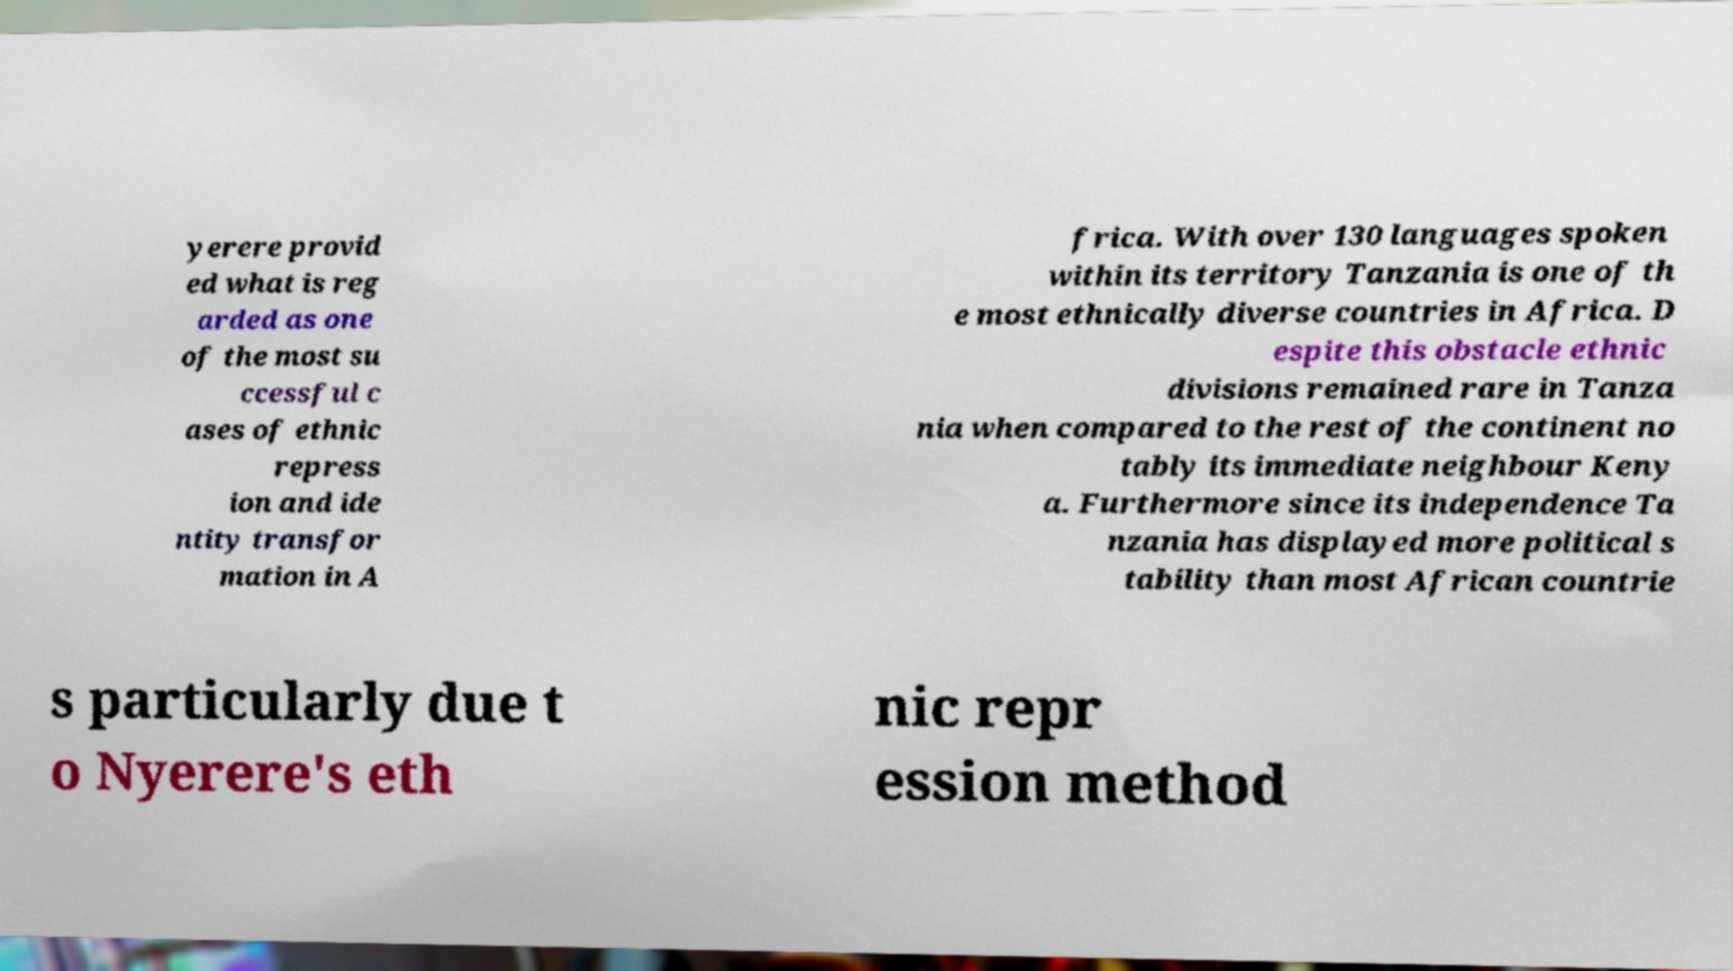Can you read and provide the text displayed in the image?This photo seems to have some interesting text. Can you extract and type it out for me? yerere provid ed what is reg arded as one of the most su ccessful c ases of ethnic repress ion and ide ntity transfor mation in A frica. With over 130 languages spoken within its territory Tanzania is one of th e most ethnically diverse countries in Africa. D espite this obstacle ethnic divisions remained rare in Tanza nia when compared to the rest of the continent no tably its immediate neighbour Keny a. Furthermore since its independence Ta nzania has displayed more political s tability than most African countrie s particularly due t o Nyerere's eth nic repr ession method 